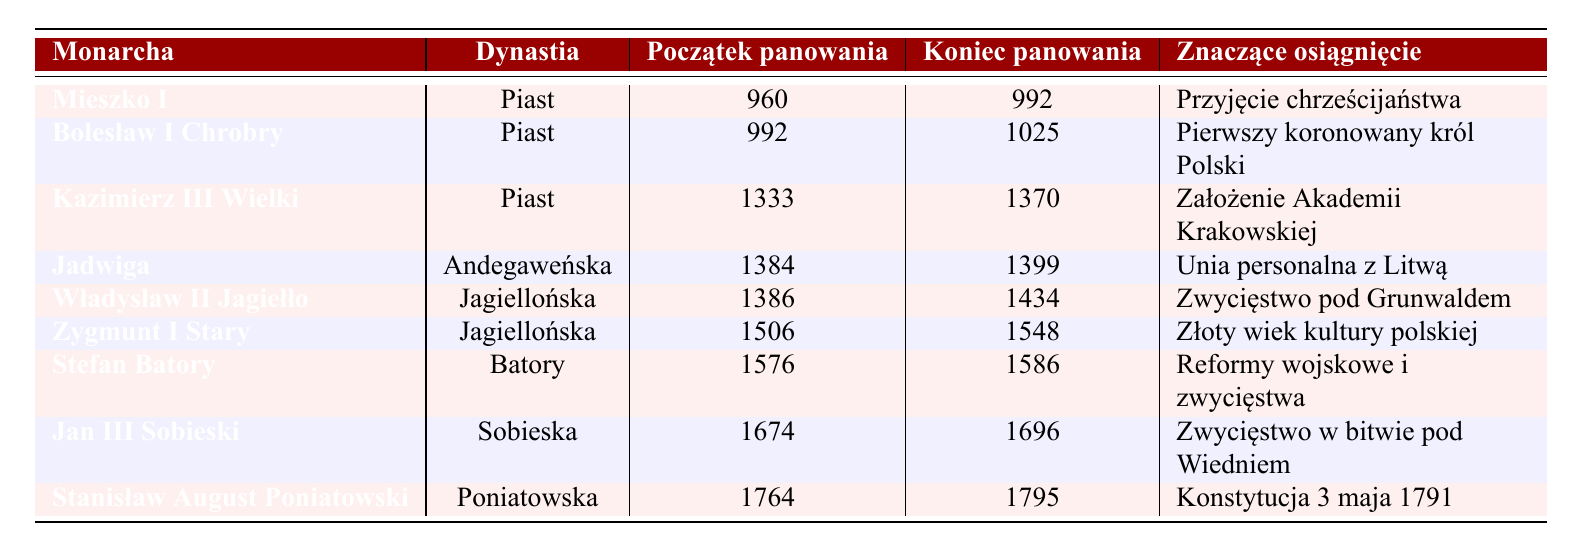What is the notable achievement of Kazimierz III Wielki? The table shows Kazimierz III Wielki's notable achievement as "Founded Kraków Academy."
Answer: Founded Kraków Academy Who was the first crowned King of Poland? According to the table, Bolesław I Chrobry is noted as the first crowned King of Poland.
Answer: Bolesław I Chrobry How long did Mieszko I reign? Mieszko I's reign started in 960 and ended in 992. The difference between 992 and 960 is 32 years, meaning he reigned for 32 years.
Answer: 32 years Which monarch is associated with the Battle of Vienna? The table indicates that Jan III Sobieski is associated with the Victory at the Battle of Vienna.
Answer: Jan III Sobieski Was Jadwiga part of the Piast dynasty? The table shows that Jadwiga was from the Anjou dynasty, not the Piast dynasty. Therefore, the answer is no.
Answer: No Which monarchs had reigns in the 14th century? From the table, Kazimierz III Wielki (reigning 1333-1370) and Jadwiga (reigning 1384-1399) are the monarchs with reigns in the 14th century, meaning there are two of them.
Answer: 2 What achievements are shared by the monarchs of the Jagiellon dynasty? The table indicates both Władysław II Jagiełło and Zygmunt I Stary are from the Jagiellon dynasty. Their notable achievements include "Victory at Grunwald" and "Golden Age of Polish culture," but they are separate achievements. So, the shared characteristic is their dynasty.
Answer: Jagiellon dynasty Which monarch reigned for the longest period? The reign lengths can be calculated: Mieszko I (32 years), Bolesław I Chrobry (33 years), Kazimierz III Wielki (37 years), Jadwiga (15 years), Władysław II Jagiełło (48 years), Zygmunt I Stary (42 years), Stefan Batory (10 years), Jan III Sobieski (22 years), Stanisław August Poniatowski (31 years). Władysław II Jagiełło reigned the longest with 48 years.
Answer: Władysław II Jagiełło What is the time span of Stanisław August Poniatowski's reign? The reign started in 1764 and ended in 1795. The difference is calculated by subtracting: 1795 - 1764 = 31 years.
Answer: 31 years Did Kazimierz III Wielki come before or after Jadwiga? The table shows Kazimierz III Wielki's reign was from 1333 to 1370, and Jadwiga's from 1384 to 1399, which indicates that Kazimierz III Wielki reigned before Jadwiga.
Answer: Before Count the number of monarchs who had significant achievements related to military. From the table, Stefan Batory (military reforms and victories) and Jan III Sobieski (Victory at the Battle of Vienna) are noted for military achievements. Thus, there are two such monarchs.
Answer: 2 